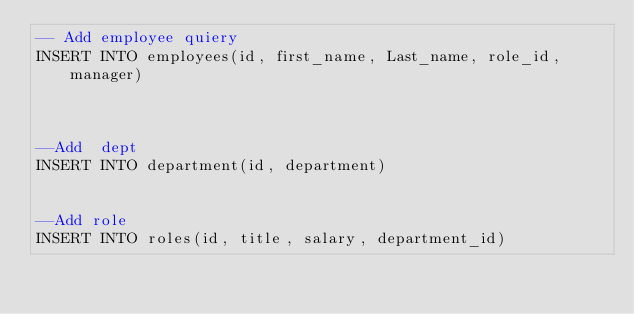Convert code to text. <code><loc_0><loc_0><loc_500><loc_500><_SQL_>-- Add employee quiery
INSERT INTO employees(id, first_name, Last_name, role_id, manager)



--Add  dept
INSERT INTO department(id, department)


--Add role 
INSERT INTO roles(id, title, salary, department_id) </code> 